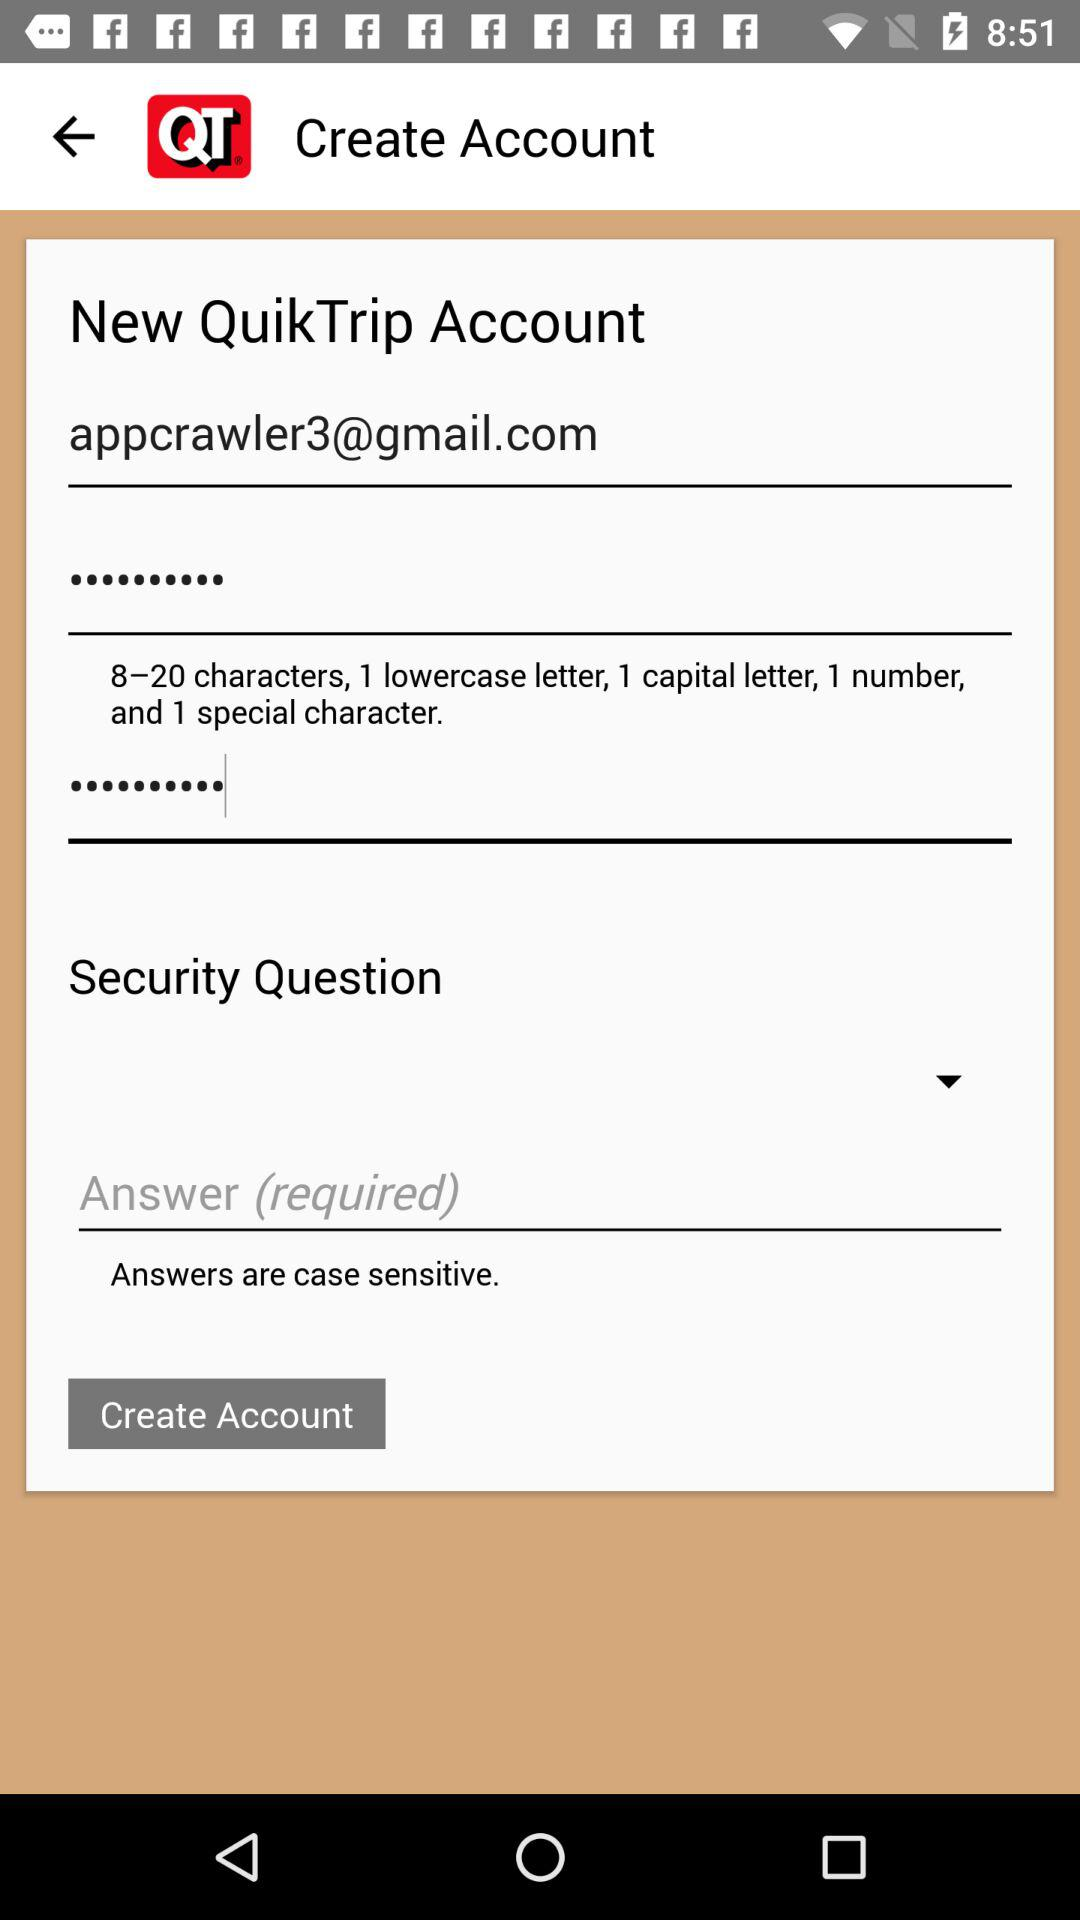How many text inputs are required for creating an account?
Answer the question using a single word or phrase. 4 